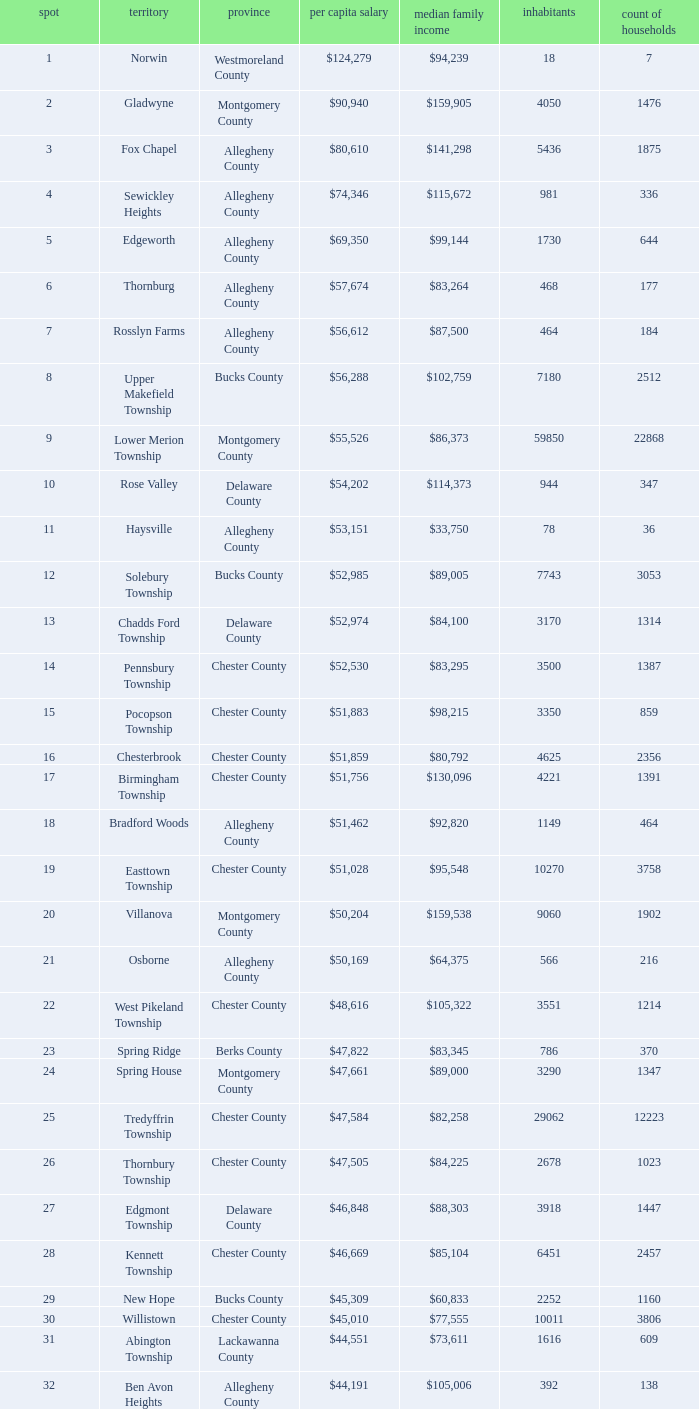Can you give me this table as a dict? {'header': ['spot', 'territory', 'province', 'per capita salary', 'median family income', 'inhabitants', 'count of households'], 'rows': [['1', 'Norwin', 'Westmoreland County', '$124,279', '$94,239', '18', '7'], ['2', 'Gladwyne', 'Montgomery County', '$90,940', '$159,905', '4050', '1476'], ['3', 'Fox Chapel', 'Allegheny County', '$80,610', '$141,298', '5436', '1875'], ['4', 'Sewickley Heights', 'Allegheny County', '$74,346', '$115,672', '981', '336'], ['5', 'Edgeworth', 'Allegheny County', '$69,350', '$99,144', '1730', '644'], ['6', 'Thornburg', 'Allegheny County', '$57,674', '$83,264', '468', '177'], ['7', 'Rosslyn Farms', 'Allegheny County', '$56,612', '$87,500', '464', '184'], ['8', 'Upper Makefield Township', 'Bucks County', '$56,288', '$102,759', '7180', '2512'], ['9', 'Lower Merion Township', 'Montgomery County', '$55,526', '$86,373', '59850', '22868'], ['10', 'Rose Valley', 'Delaware County', '$54,202', '$114,373', '944', '347'], ['11', 'Haysville', 'Allegheny County', '$53,151', '$33,750', '78', '36'], ['12', 'Solebury Township', 'Bucks County', '$52,985', '$89,005', '7743', '3053'], ['13', 'Chadds Ford Township', 'Delaware County', '$52,974', '$84,100', '3170', '1314'], ['14', 'Pennsbury Township', 'Chester County', '$52,530', '$83,295', '3500', '1387'], ['15', 'Pocopson Township', 'Chester County', '$51,883', '$98,215', '3350', '859'], ['16', 'Chesterbrook', 'Chester County', '$51,859', '$80,792', '4625', '2356'], ['17', 'Birmingham Township', 'Chester County', '$51,756', '$130,096', '4221', '1391'], ['18', 'Bradford Woods', 'Allegheny County', '$51,462', '$92,820', '1149', '464'], ['19', 'Easttown Township', 'Chester County', '$51,028', '$95,548', '10270', '3758'], ['20', 'Villanova', 'Montgomery County', '$50,204', '$159,538', '9060', '1902'], ['21', 'Osborne', 'Allegheny County', '$50,169', '$64,375', '566', '216'], ['22', 'West Pikeland Township', 'Chester County', '$48,616', '$105,322', '3551', '1214'], ['23', 'Spring Ridge', 'Berks County', '$47,822', '$83,345', '786', '370'], ['24', 'Spring House', 'Montgomery County', '$47,661', '$89,000', '3290', '1347'], ['25', 'Tredyffrin Township', 'Chester County', '$47,584', '$82,258', '29062', '12223'], ['26', 'Thornbury Township', 'Chester County', '$47,505', '$84,225', '2678', '1023'], ['27', 'Edgmont Township', 'Delaware County', '$46,848', '$88,303', '3918', '1447'], ['28', 'Kennett Township', 'Chester County', '$46,669', '$85,104', '6451', '2457'], ['29', 'New Hope', 'Bucks County', '$45,309', '$60,833', '2252', '1160'], ['30', 'Willistown', 'Chester County', '$45,010', '$77,555', '10011', '3806'], ['31', 'Abington Township', 'Lackawanna County', '$44,551', '$73,611', '1616', '609'], ['32', 'Ben Avon Heights', 'Allegheny County', '$44,191', '$105,006', '392', '138'], ['33', 'Bala-Cynwyd', 'Montgomery County', '$44,027', '$78,932', '9336', '3726'], ['34', 'Lower Makefield Township', 'Bucks County', '$43,983', '$98,090', '32681', '11706'], ['35', 'Blue Bell', 'Montgomery County', '$43,813', '$94,160', '6395', '2434'], ['36', 'West Vincent Township', 'Chester County', '$43,500', '$92,024', '3170', '1077'], ['37', 'Mount Gretna', 'Lebanon County', '$43,470', '$62,917', '242', '117'], ['38', 'Schuylkill Township', 'Chester County', '$43,379', '$86,092', '6960', '2536'], ['39', 'Fort Washington', 'Montgomery County', '$43,090', '$103,469', '3680', '1161'], ['40', 'Marshall Township', 'Allegheny County', '$42,856', '$102,351', '5996', '1944'], ['41', 'Woodside', 'Bucks County', '$42,653', '$121,151', '2575', '791'], ['42', 'Wrightstown Township', 'Bucks County', '$42,623', '$82,875', '2839', '971'], ['43', 'Upper St.Clair Township', 'Allegheny County', '$42,413', '$87,581', '20053', '6966'], ['44', 'Seven Springs', 'Fayette County', '$42,131', '$48,750', '127', '63'], ['45', 'Charlestown Township', 'Chester County', '$41,878', '$89,813', '4051', '1340'], ['46', 'Lower Gwynedd Township', 'Montgomery County', '$41,868', '$74,351', '10422', '4177'], ['47', 'Whitpain Township', 'Montgomery County', '$41,739', '$88,933', '18562', '6960'], ['48', 'Bell Acres', 'Allegheny County', '$41,202', '$61,094', '1382', '520'], ['49', 'Penn Wynne', 'Montgomery County', '$41,199', '$78,398', '5382', '2072'], ['50', 'East Bradford Township', 'Chester County', '$41,158', '$100,732', '9405', '3076'], ['51', 'Swarthmore', 'Delaware County', '$40,482', '$82,653', '6170', '1993'], ['52', 'Lafayette Hill', 'Montgomery County', '$40,363', '$84,835', '10226', '3783'], ['53', 'Lower Moreland Township', 'Montgomery County', '$40,129', '$82,597', '11281', '4112'], ['54', 'Radnor Township', 'Delaware County', '$39,813', '$74,272', '30878', '10347'], ['55', 'Whitemarsh Township', 'Montgomery County', '$39,785', '$78,630', '16702', '6179'], ['56', 'Upper Providence Township', 'Delaware County', '$39,532', '$71,166', '10509', '4075'], ['57', 'Newtown Township', 'Delaware County', '$39,364', '$65,924', '11700', '4549'], ['58', 'Adams Township', 'Butler County', '$39,204', '$65,357', '6774', '2382'], ['59', 'Edgewood', 'Allegheny County', '$39,188', '$52,153', '3311', '1639'], ['60', 'Dresher', 'Montgomery County', '$38,865', '$99,231', '5610', '1765'], ['61', 'Sewickley Hills', 'Allegheny County', '$38,681', '$79,466', '652', '225'], ['62', 'Exton', 'Chester County', '$38,589', '$68,240', '4267', '2053'], ['63', 'East Marlborough Township', 'Chester County', '$38,090', '$95,812', '6317', '2131'], ['64', 'Doylestown Township', 'Bucks County', '$38,031', '$81,226', '17619', '5999'], ['65', 'Upper Dublin Township', 'Montgomery County', '$37,994', '$80,093', '25878', '9174'], ['66', 'Churchill', 'Allegheny County', '$37,964', '$67,321', '3566', '1519'], ['67', 'Franklin Park', 'Allegheny County', '$37,924', '$87,627', '11364', '3866'], ['68', 'East Goshen Township', 'Chester County', '$37,775', '$64,777', '16824', '7165'], ['69', 'Chester Heights', 'Delaware County', '$37,707', '$70,236', '2481', '1056'], ['70', 'McMurray', 'Washington County', '$37,364', '$81,736', '4726', '1582'], ['71', 'Wyomissing', 'Berks County', '$37,313', '$54,681', '8587', '3359'], ['72', 'Heath Township', 'Jefferson County', '$37,309', '$42,500', '160', '77'], ['73', 'Aleppo Township', 'Allegheny County', '$37,187', '$59,167', '1039', '483'], ['74', 'Westtown Township', 'Chester County', '$36,894', '$85,049', '10352', '3705'], ['75', 'Thompsonville', 'Washington County', '$36,853', '$75,000', '3592', '1228'], ['76', 'Flying Hills', 'Berks County', '$36,822', '$59,596', '1191', '592'], ['77', 'Newlin Township', 'Chester County', '$36,804', '$68,828', '1150', '429'], ['78', 'Wyndmoor', 'Montgomery County', '$36,205', '$72,219', '5601', '2144'], ['79', 'Peters Township', 'Washington County', '$36,159', '$77,442', '17566', '6026'], ['80', 'Ardmore', 'Montgomery County', '$36,111', '$60,966', '12616', '5529'], ['81', 'Clarks Green', 'Lackawanna County', '$35,975', '$61,250', '1630', '616'], ['82', 'London Britain Township', 'Chester County', '$35,761', '$93,521', '2797', '957'], ['83', 'Buckingham Township', 'Bucks County', '$35,735', '$82,376', '16422', '5711'], ['84', 'Devon-Berwyn', 'Chester County', '$35,551', '$74,886', '5067', '1978'], ['85', 'North Abington Township', 'Lackawanna County', '$35,537', '$57,917', '782', '258'], ['86', 'Malvern', 'Chester County', '$35,477', '$62,308', '3059', '1361'], ['87', 'Pine Township', 'Allegheny County', '$35,202', '$85,817', '7683', '2411'], ['88', 'Narberth', 'Montgomery County', '$35,165', '$60,408', '4233', '1904'], ['89', 'West Whiteland Township', 'Chester County', '$35,031', '$71,545', '16499', '6618'], ['90', 'Timber Hills', 'Lebanon County', '$34,974', '$55,938', '329', '157'], ['91', 'Upper Merion Township', 'Montgomery County', '$34,961', '$65,636', '26863', '11575'], ['92', 'Homewood', 'Beaver County', '$34,486', '$33,333', '147', '59'], ['93', 'Newtown Township', 'Bucks County', '$34,335', '$80,532', '18206', '6761'], ['94', 'Tinicum Township', 'Bucks County', '$34,321', '$60,843', '4206', '1674'], ['95', 'Worcester Township', 'Montgomery County', '$34,264', '$77,200', '7789', '2896'], ['96', 'Wyomissing Hills', 'Berks County', '$34,024', '$61,364', '2568', '986'], ['97', 'Woodbourne', 'Bucks County', '$33,821', '$107,913', '3512', '1008'], ['98', 'Concord Township', 'Delaware County', '$33,800', '$85,503', '9933', '3384'], ['99', 'Uwchlan Township', 'Chester County', '$33,785', '$81,985', '16576', '5921']]} What is the median household income for Woodside? $121,151. 